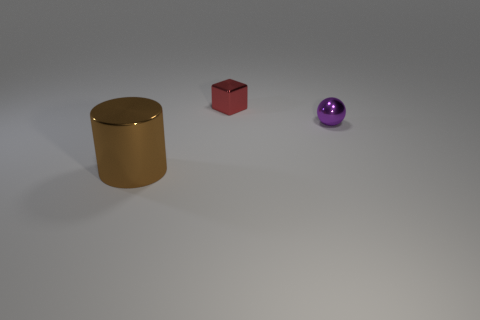Is there any other thing that has the same size as the brown metallic cylinder?
Offer a terse response. No. Does the tiny purple shiny object have the same shape as the brown object?
Offer a very short reply. No. There is a shiny thing that is in front of the small shiny object in front of the tiny red shiny thing; how big is it?
Provide a short and direct response. Large. What number of metallic cylinders have the same color as the shiny block?
Give a very brief answer. 0. What size is the brown shiny thing?
Your answer should be compact. Large. Do the brown cylinder and the red thing have the same size?
Keep it short and to the point. No. There is a metal object that is both to the left of the purple object and behind the large brown cylinder; what color is it?
Offer a very short reply. Red. What number of other small blue balls are the same material as the sphere?
Provide a short and direct response. 0. What number of large yellow metallic cubes are there?
Your response must be concise. 0. There is a purple object; is its size the same as the brown metal thing that is on the left side of the tiny red object?
Offer a very short reply. No. 